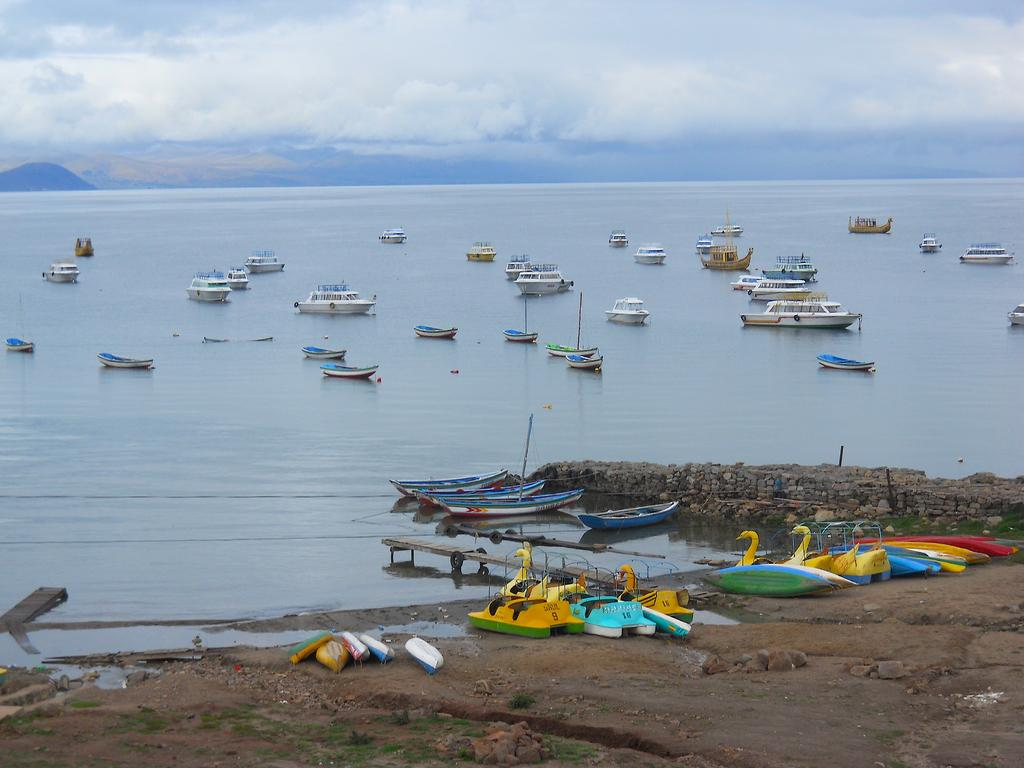What type of vehicles are in the image? There are boats in the image. What is the primary element surrounding the boats? There is water visible in the image. How would you describe the weather in the image? The sky is cloudy in the image. What type of ring is the yam wearing on its finger in the image? There is no yam or ring present in the image; it features boats on water with a cloudy sky. 